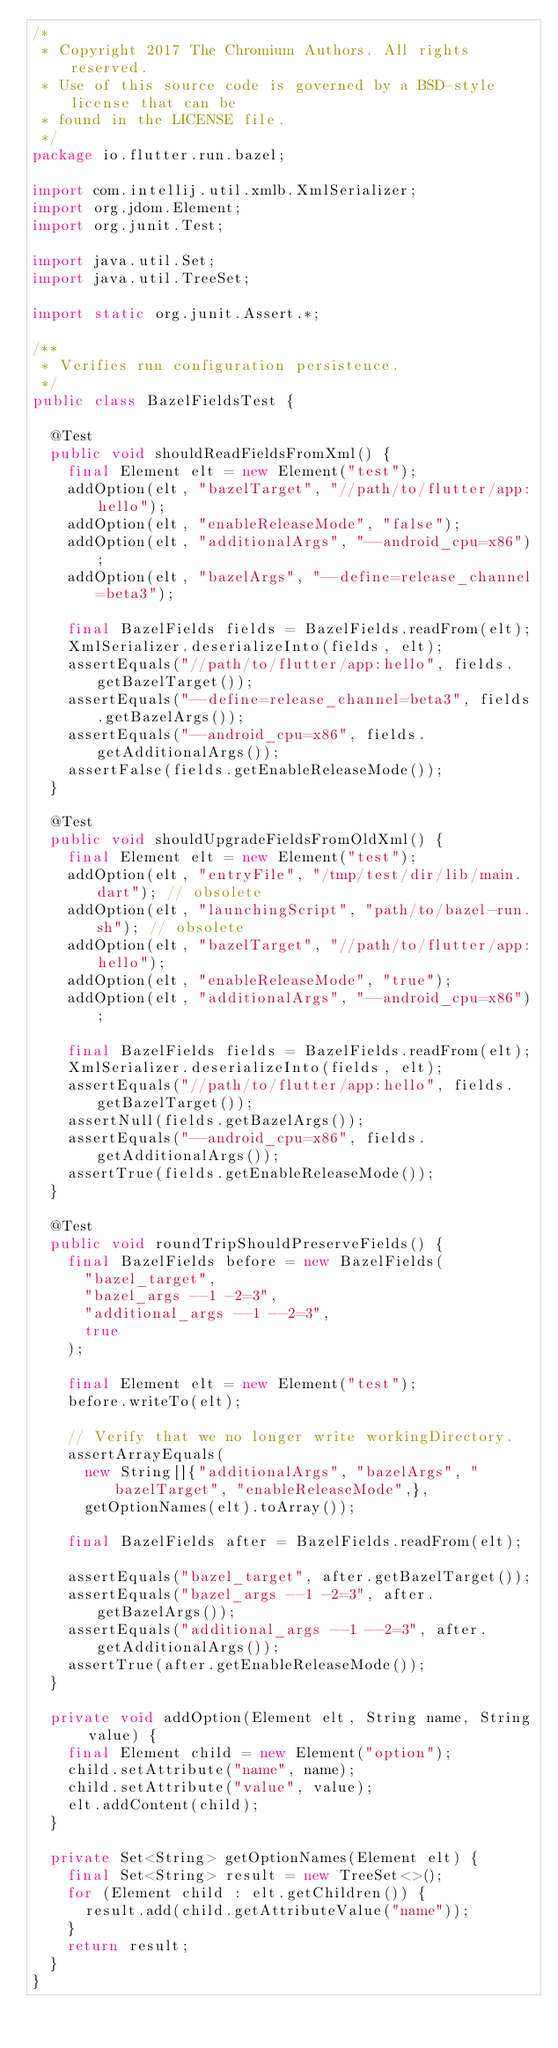<code> <loc_0><loc_0><loc_500><loc_500><_Java_>/*
 * Copyright 2017 The Chromium Authors. All rights reserved.
 * Use of this source code is governed by a BSD-style license that can be
 * found in the LICENSE file.
 */
package io.flutter.run.bazel;

import com.intellij.util.xmlb.XmlSerializer;
import org.jdom.Element;
import org.junit.Test;

import java.util.Set;
import java.util.TreeSet;

import static org.junit.Assert.*;

/**
 * Verifies run configuration persistence.
 */
public class BazelFieldsTest {

  @Test
  public void shouldReadFieldsFromXml() {
    final Element elt = new Element("test");
    addOption(elt, "bazelTarget", "//path/to/flutter/app:hello");
    addOption(elt, "enableReleaseMode", "false");
    addOption(elt, "additionalArgs", "--android_cpu=x86");
    addOption(elt, "bazelArgs", "--define=release_channel=beta3");

    final BazelFields fields = BazelFields.readFrom(elt);
    XmlSerializer.deserializeInto(fields, elt);
    assertEquals("//path/to/flutter/app:hello", fields.getBazelTarget());
    assertEquals("--define=release_channel=beta3", fields.getBazelArgs());
    assertEquals("--android_cpu=x86", fields.getAdditionalArgs());
    assertFalse(fields.getEnableReleaseMode());
  }

  @Test
  public void shouldUpgradeFieldsFromOldXml() {
    final Element elt = new Element("test");
    addOption(elt, "entryFile", "/tmp/test/dir/lib/main.dart"); // obsolete
    addOption(elt, "launchingScript", "path/to/bazel-run.sh"); // obsolete
    addOption(elt, "bazelTarget", "//path/to/flutter/app:hello");
    addOption(elt, "enableReleaseMode", "true");
    addOption(elt, "additionalArgs", "--android_cpu=x86");

    final BazelFields fields = BazelFields.readFrom(elt);
    XmlSerializer.deserializeInto(fields, elt);
    assertEquals("//path/to/flutter/app:hello", fields.getBazelTarget());
    assertNull(fields.getBazelArgs());
    assertEquals("--android_cpu=x86", fields.getAdditionalArgs());
    assertTrue(fields.getEnableReleaseMode());
  }

  @Test
  public void roundTripShouldPreserveFields() {
    final BazelFields before = new BazelFields(
      "bazel_target",
      "bazel_args --1 -2=3",
      "additional_args --1 --2=3",
      true
    );

    final Element elt = new Element("test");
    before.writeTo(elt);

    // Verify that we no longer write workingDirectory.
    assertArrayEquals(
      new String[]{"additionalArgs", "bazelArgs", "bazelTarget", "enableReleaseMode",},
      getOptionNames(elt).toArray());

    final BazelFields after = BazelFields.readFrom(elt);

    assertEquals("bazel_target", after.getBazelTarget());
    assertEquals("bazel_args --1 -2=3", after.getBazelArgs());
    assertEquals("additional_args --1 --2=3", after.getAdditionalArgs());
    assertTrue(after.getEnableReleaseMode());
  }

  private void addOption(Element elt, String name, String value) {
    final Element child = new Element("option");
    child.setAttribute("name", name);
    child.setAttribute("value", value);
    elt.addContent(child);
  }

  private Set<String> getOptionNames(Element elt) {
    final Set<String> result = new TreeSet<>();
    for (Element child : elt.getChildren()) {
      result.add(child.getAttributeValue("name"));
    }
    return result;
  }
}
</code> 